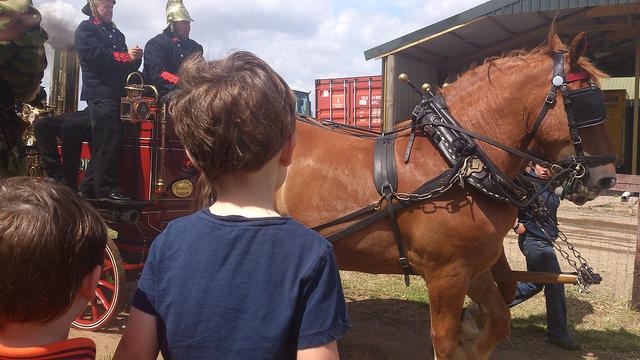What color is the horse?
Short answer required. Brown. What color is the blanket on the back of the horse?
Answer briefly. Brown. Can the horse use its periphery vision?
Keep it brief. No. What animal is the man riding?
Concise answer only. Horse. Do the kids like horses?
Short answer required. Yes. 